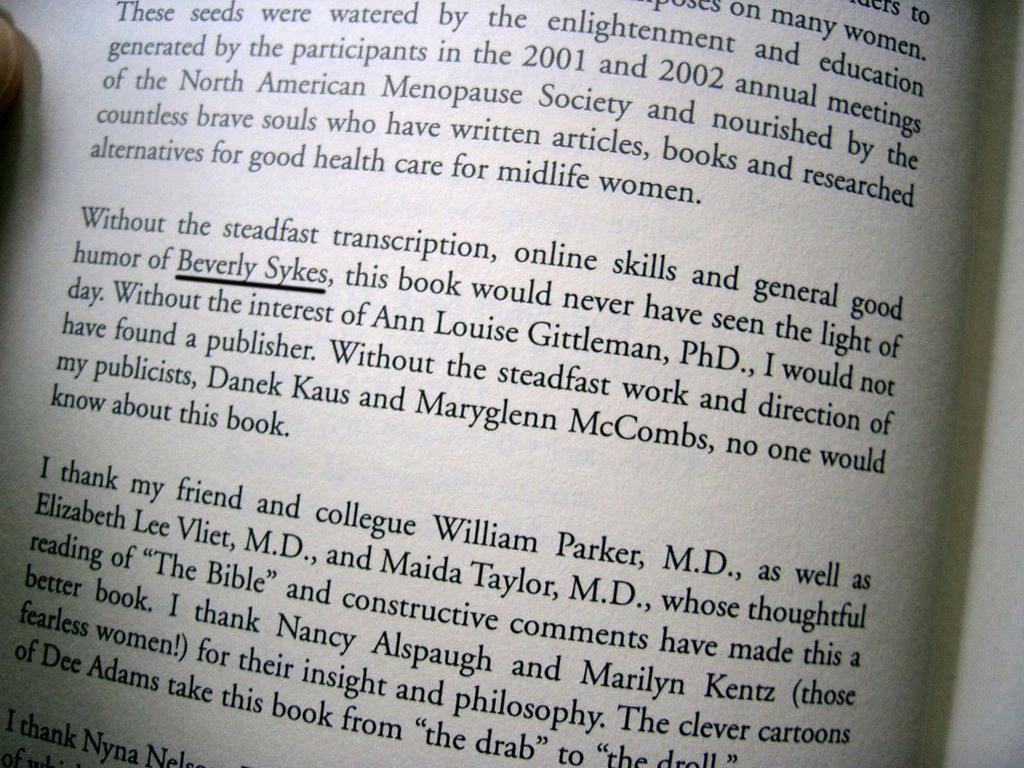Provide a one-sentence caption for the provided image. An open book with the name "Beverly Sykes" underlined. 